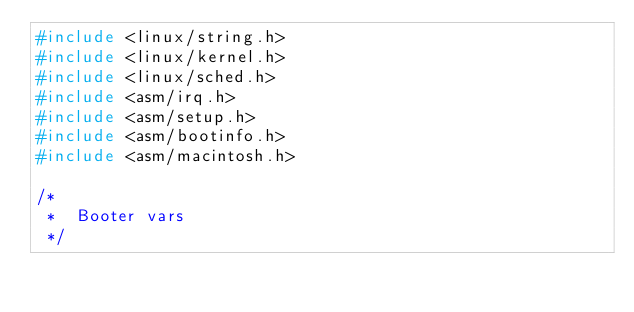Convert code to text. <code><loc_0><loc_0><loc_500><loc_500><_C_>#include <linux/string.h>
#include <linux/kernel.h>
#include <linux/sched.h>
#include <asm/irq.h>
#include <asm/setup.h>
#include <asm/bootinfo.h>
#include <asm/macintosh.h>

/*
 *	Booter vars
 */
 </code> 